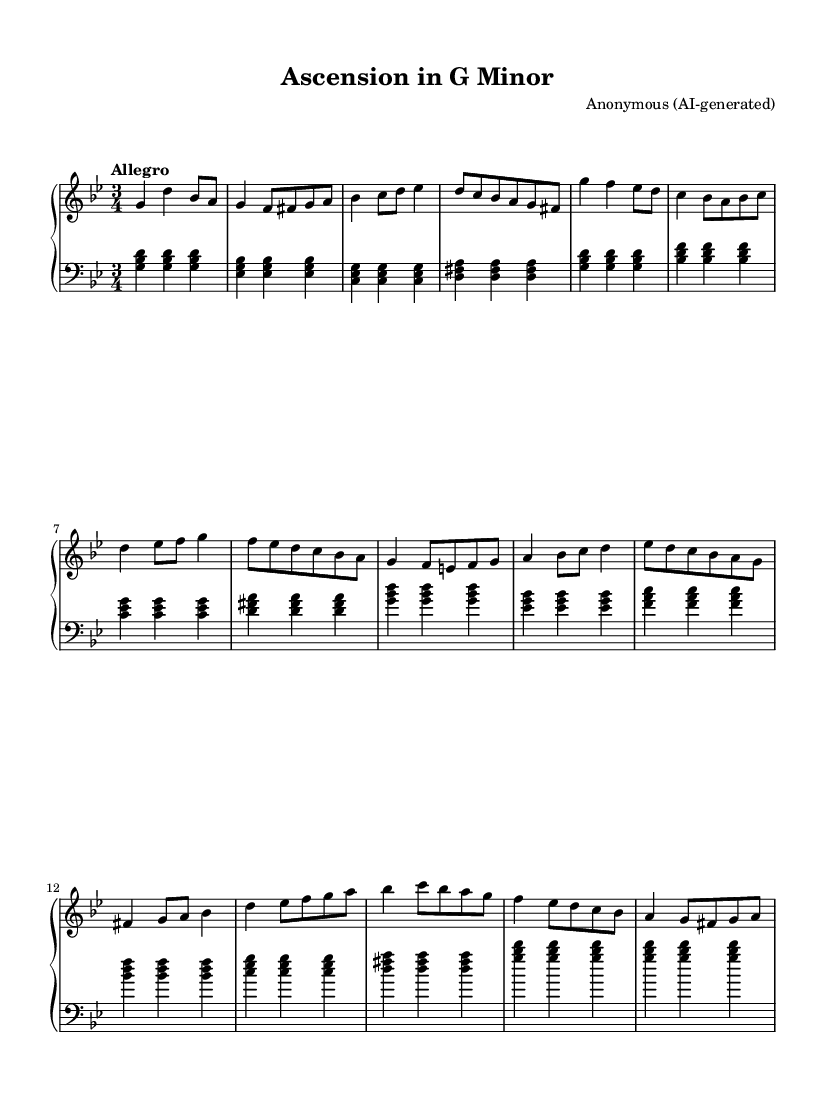What is the key signature of this music? The key signature reveals that the piece is in G minor, which has two flats (B flat and E flat). This can be confirmed by looking at the key signature located at the beginning of the staff.
Answer: G minor What is the time signature of this music? The time signature is found at the beginning of the sheet music and shows that the piece is in three beats per measure, indicated by 3/4.
Answer: 3/4 What is the tempo marking of this composition? The tempo marking is indicated in the piece, stating "Allegro," which signifies a fast and lively tempo. This is noted in a text format above the staff.
Answer: Allegro How many measures are in Theme A of this composition? By counting the measures specifically within the section labeled as Theme A in the sheet music, we can see there are eight measures.
Answer: Eight What types of chords are predominantly used in the left hand? The left hand primarily uses triadic chords, which consist of three notes stacked in thirds, typical of the harmonic structure in Baroque music.
Answer: Triadic chords Which section contains the most intricate melodic variations? Analyzing the right hand of the sheet music, the theme labeled as Theme B contains the most intricate melodic variations with multiple note sequences and complexities.
Answer: Theme B Which instrument is specified for the performance of this piece? The header specifies that the instrument originally intended for this music is the harpsichord, which is uniquely suited for Baroque compositions due to its timbre and playing technique.
Answer: Harpsichord 